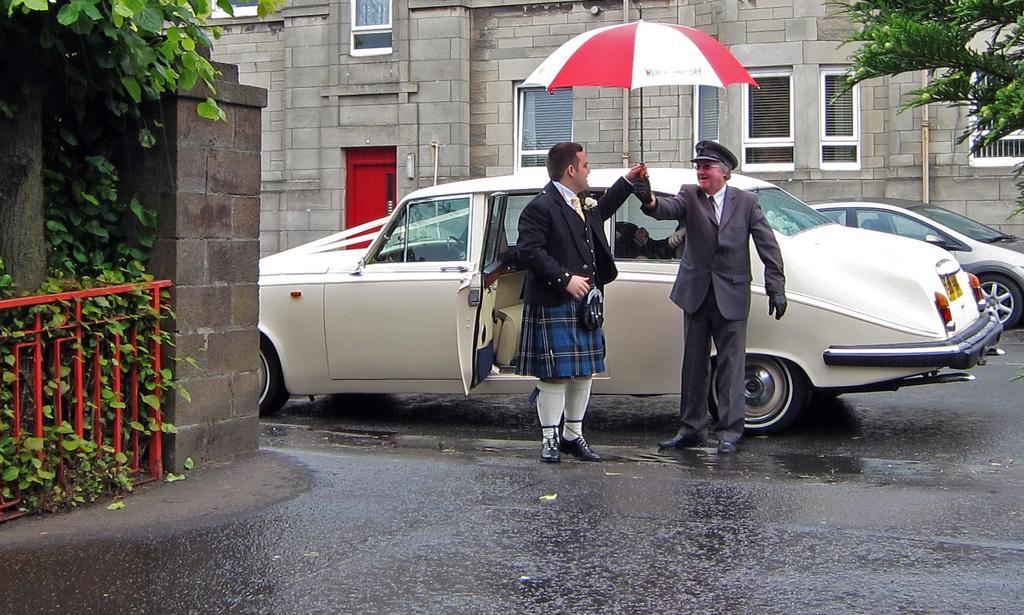Can you describe this image briefly? This image is taken outdoors. At the bottom of the image there is a road. In the background there is a building. On the left side of the image there is a tree and there are many plants. There is a railing and there is a wall. In the middle of the image a car is parked on the road. Two men are standing on the road and they are holding an umbrella. On the right side of the image there is a tree and a car is parked on the road. 